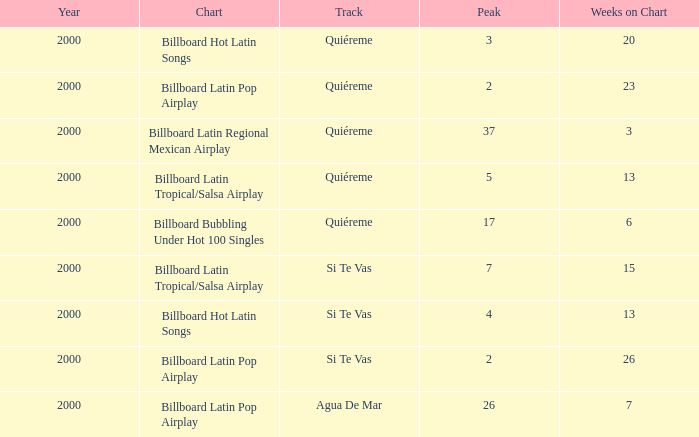How many weeks are there at least in a year prior to 2000? None. 